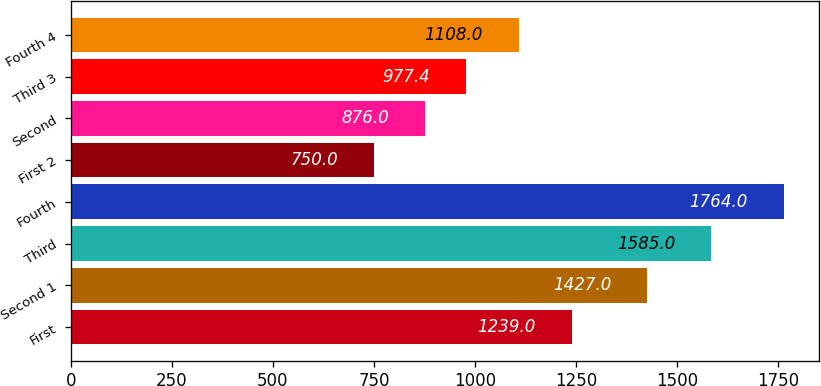<chart> <loc_0><loc_0><loc_500><loc_500><bar_chart><fcel>First<fcel>Second 1<fcel>Third<fcel>Fourth<fcel>First 2<fcel>Second<fcel>Third 3<fcel>Fourth 4<nl><fcel>1239<fcel>1427<fcel>1585<fcel>1764<fcel>750<fcel>876<fcel>977.4<fcel>1108<nl></chart> 